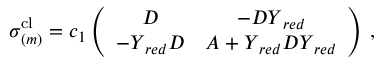Convert formula to latex. <formula><loc_0><loc_0><loc_500><loc_500>\begin{array} { r } { \sigma _ { ( m ) } ^ { c l } = c _ { 1 } \left ( \begin{array} { c c } { D } & { - D Y _ { r e d } } \\ { - Y _ { r e d } D } & { A + Y _ { r e d } D Y _ { r e d } } \end{array} \right ) \, , } \end{array}</formula> 